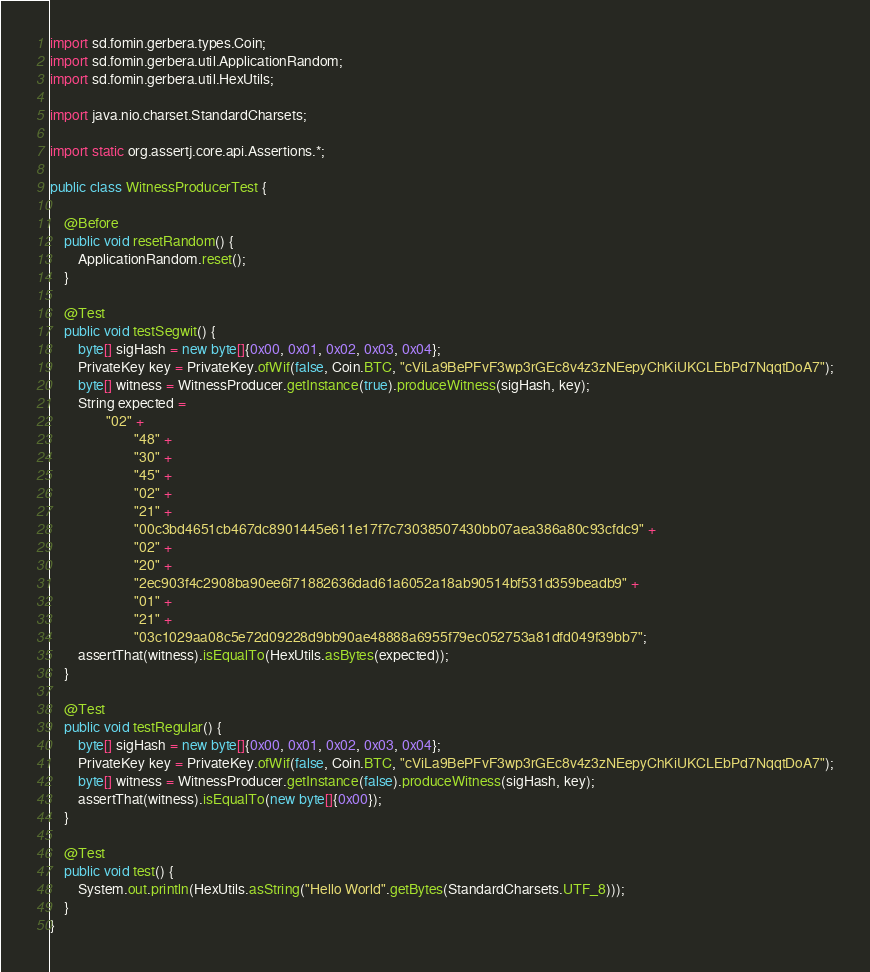<code> <loc_0><loc_0><loc_500><loc_500><_Java_>import sd.fomin.gerbera.types.Coin;
import sd.fomin.gerbera.util.ApplicationRandom;
import sd.fomin.gerbera.util.HexUtils;

import java.nio.charset.StandardCharsets;

import static org.assertj.core.api.Assertions.*;

public class WitnessProducerTest {

    @Before
    public void resetRandom() {
        ApplicationRandom.reset();
    }

    @Test
    public void testSegwit() {
        byte[] sigHash = new byte[]{0x00, 0x01, 0x02, 0x03, 0x04};
        PrivateKey key = PrivateKey.ofWif(false, Coin.BTC, "cViLa9BePFvF3wp3rGEc8v4z3zNEepyChKiUKCLEbPd7NqqtDoA7");
        byte[] witness = WitnessProducer.getInstance(true).produceWitness(sigHash, key);
        String expected =
                "02" +
                        "48" +
                        "30" +
                        "45" +
                        "02" +
                        "21" +
                        "00c3bd4651cb467dc8901445e611e17f7c73038507430bb07aea386a80c93cfdc9" +
                        "02" +
                        "20" +
                        "2ec903f4c2908ba90ee6f71882636dad61a6052a18ab90514bf531d359beadb9" +
                        "01" +
                        "21" +
                        "03c1029aa08c5e72d09228d9bb90ae48888a6955f79ec052753a81dfd049f39bb7";
        assertThat(witness).isEqualTo(HexUtils.asBytes(expected));
    }

    @Test
    public void testRegular() {
        byte[] sigHash = new byte[]{0x00, 0x01, 0x02, 0x03, 0x04};
        PrivateKey key = PrivateKey.ofWif(false, Coin.BTC, "cViLa9BePFvF3wp3rGEc8v4z3zNEepyChKiUKCLEbPd7NqqtDoA7");
        byte[] witness = WitnessProducer.getInstance(false).produceWitness(sigHash, key);
        assertThat(witness).isEqualTo(new byte[]{0x00});
    }

    @Test
    public void test() {
        System.out.println(HexUtils.asString("Hello World".getBytes(StandardCharsets.UTF_8)));
    }
}
</code> 